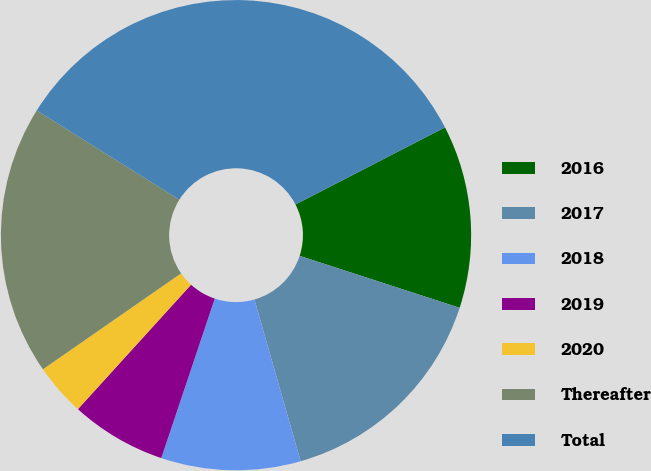Convert chart. <chart><loc_0><loc_0><loc_500><loc_500><pie_chart><fcel>2016<fcel>2017<fcel>2018<fcel>2019<fcel>2020<fcel>Thereafter<fcel>Total<nl><fcel>12.58%<fcel>15.57%<fcel>9.58%<fcel>6.59%<fcel>3.6%<fcel>18.56%<fcel>33.52%<nl></chart> 